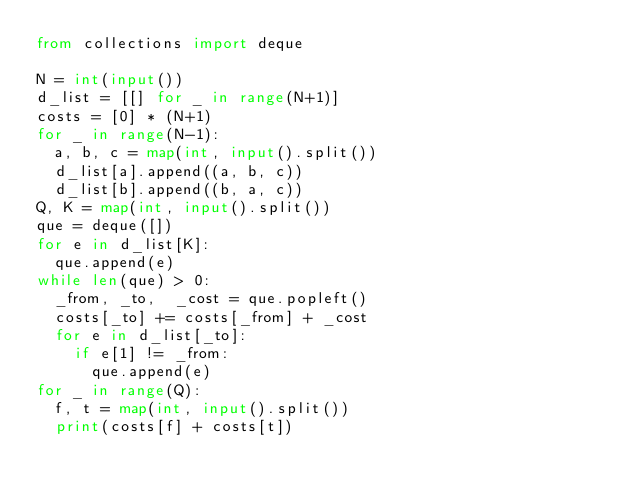<code> <loc_0><loc_0><loc_500><loc_500><_Python_>from collections import deque

N = int(input())
d_list = [[] for _ in range(N+1)]
costs = [0] * (N+1)
for _ in range(N-1):
  a, b, c = map(int, input().split())
  d_list[a].append((a, b, c))
  d_list[b].append((b, a, c))
Q, K = map(int, input().split())
que = deque([])
for e in d_list[K]:
  que.append(e)
while len(que) > 0:
  _from, _to,  _cost = que.popleft()
  costs[_to] += costs[_from] + _cost
  for e in d_list[_to]:
    if e[1] != _from:
      que.append(e)
for _ in range(Q):
  f, t = map(int, input().split())
  print(costs[f] + costs[t])
  

  </code> 